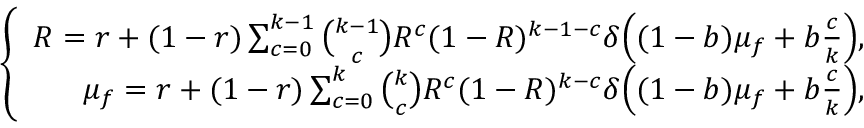Convert formula to latex. <formula><loc_0><loc_0><loc_500><loc_500>\left \{ \begin{array} { r } { R = r + ( 1 - r ) \sum _ { c = 0 } ^ { k - 1 } \binom { k - 1 } { c } R ^ { c } ( 1 - R ) ^ { k - 1 - c } \delta \left ( ( 1 - b ) \mu _ { f } + b \frac { c } { k } \right ) , } \\ { \mu _ { f } = r + ( 1 - r ) \sum _ { c = 0 } ^ { k } \binom { k } { c } R ^ { c } ( 1 - R ) ^ { k - c } \delta \left ( ( 1 - b ) \mu _ { f } + b \frac { c } { k } \right ) , } \end{array}</formula> 